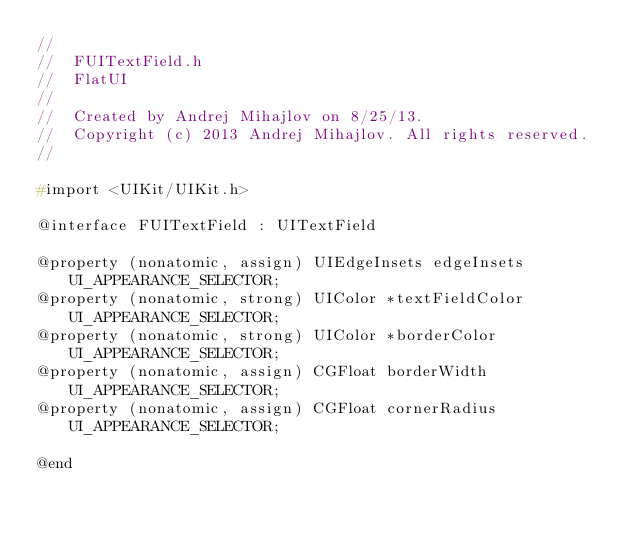Convert code to text. <code><loc_0><loc_0><loc_500><loc_500><_C_>//
//  FUITextField.h
//  FlatUI
//
//  Created by Andrej Mihajlov on 8/25/13.
//  Copyright (c) 2013 Andrej Mihajlov. All rights reserved.
//

#import <UIKit/UIKit.h>

@interface FUITextField : UITextField

@property (nonatomic, assign) UIEdgeInsets edgeInsets UI_APPEARANCE_SELECTOR;
@property (nonatomic, strong) UIColor *textFieldColor UI_APPEARANCE_SELECTOR;
@property (nonatomic, strong) UIColor *borderColor UI_APPEARANCE_SELECTOR;
@property (nonatomic, assign) CGFloat borderWidth UI_APPEARANCE_SELECTOR;
@property (nonatomic, assign) CGFloat cornerRadius UI_APPEARANCE_SELECTOR;

@end
</code> 